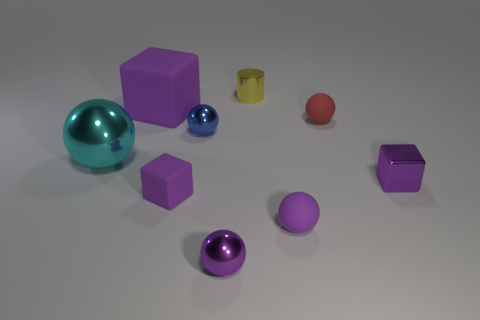Subtract all matte balls. How many balls are left? 3 Add 1 large cyan objects. How many objects exist? 10 Subtract all red spheres. How many spheres are left? 4 Subtract 2 balls. How many balls are left? 3 Subtract all green blocks. How many purple spheres are left? 2 Subtract 0 red blocks. How many objects are left? 9 Subtract all cylinders. How many objects are left? 8 Subtract all cyan spheres. Subtract all purple blocks. How many spheres are left? 4 Subtract all blue metallic spheres. Subtract all small purple rubber spheres. How many objects are left? 7 Add 5 big cyan metallic things. How many big cyan metallic things are left? 6 